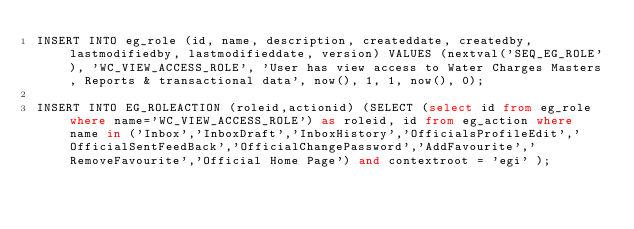Convert code to text. <code><loc_0><loc_0><loc_500><loc_500><_SQL_>INSERT INTO eg_role (id, name, description, createddate, createdby, lastmodifiedby, lastmodifieddate, version) VALUES (nextval('SEQ_EG_ROLE'), 'WC_VIEW_ACCESS_ROLE', 'User has view access to Water Charges Masters, Reports & transactional data', now(), 1, 1, now(), 0);

INSERT INTO EG_ROLEACTION (roleid,actionid) (SELECT (select id from eg_role where name='WC_VIEW_ACCESS_ROLE') as roleid, id from eg_action where name in ('Inbox','InboxDraft','InboxHistory','OfficialsProfileEdit','OfficialSentFeedBack','OfficialChangePassword','AddFavourite','RemoveFavourite','Official Home Page') and contextroot = 'egi' );</code> 